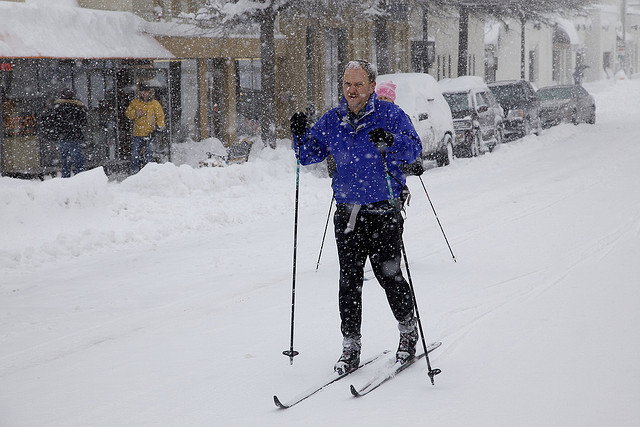<image>Is it normal to ski in the street? No, it is not normal to ski in the street. But, it can depend on where you live. Is it normal to ski in the street? It is not normal to ski in the street. However, it depends on where you live. 